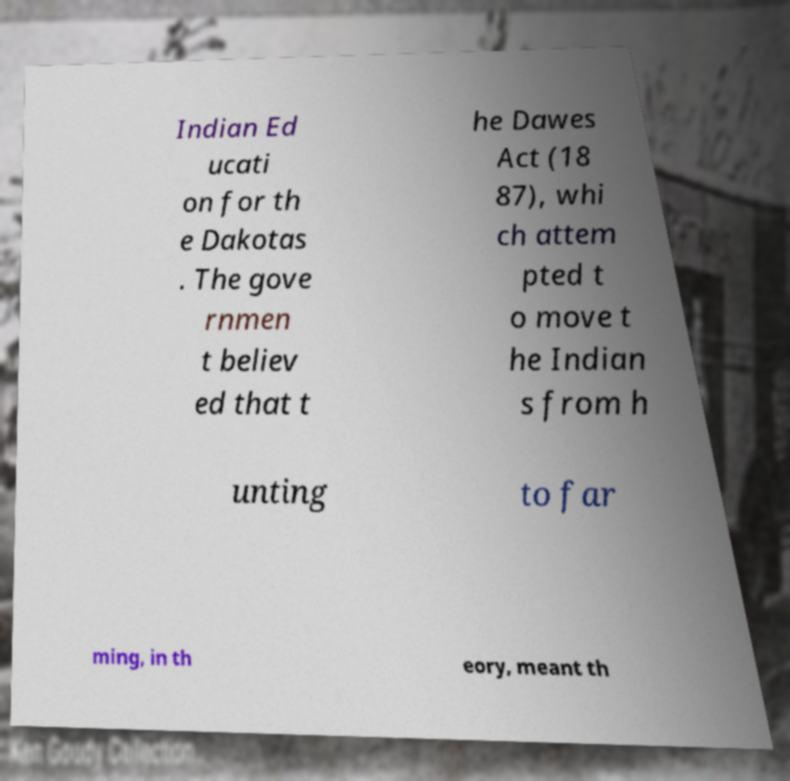What messages or text are displayed in this image? I need them in a readable, typed format. Indian Ed ucati on for th e Dakotas . The gove rnmen t believ ed that t he Dawes Act (18 87), whi ch attem pted t o move t he Indian s from h unting to far ming, in th eory, meant th 